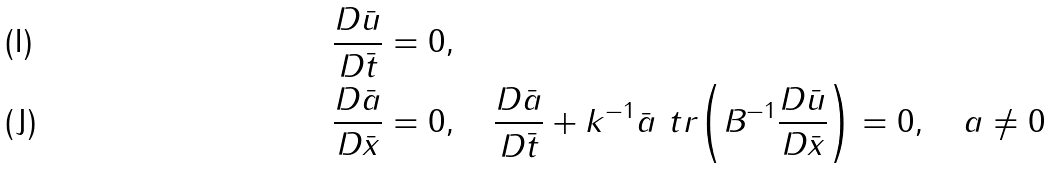<formula> <loc_0><loc_0><loc_500><loc_500>& \frac { D \bar { u } } { D \bar { t } } = 0 , \\ & \frac { D \bar { a } } { D \bar { x } } = 0 , \quad \frac { D \bar { a } } { D \bar { t } } + k ^ { - 1 } \bar { a } \ t r { \left ( B ^ { - 1 } \frac { D \bar { u } } { D \bar { x } } \right ) } = 0 , \quad a \neq 0</formula> 